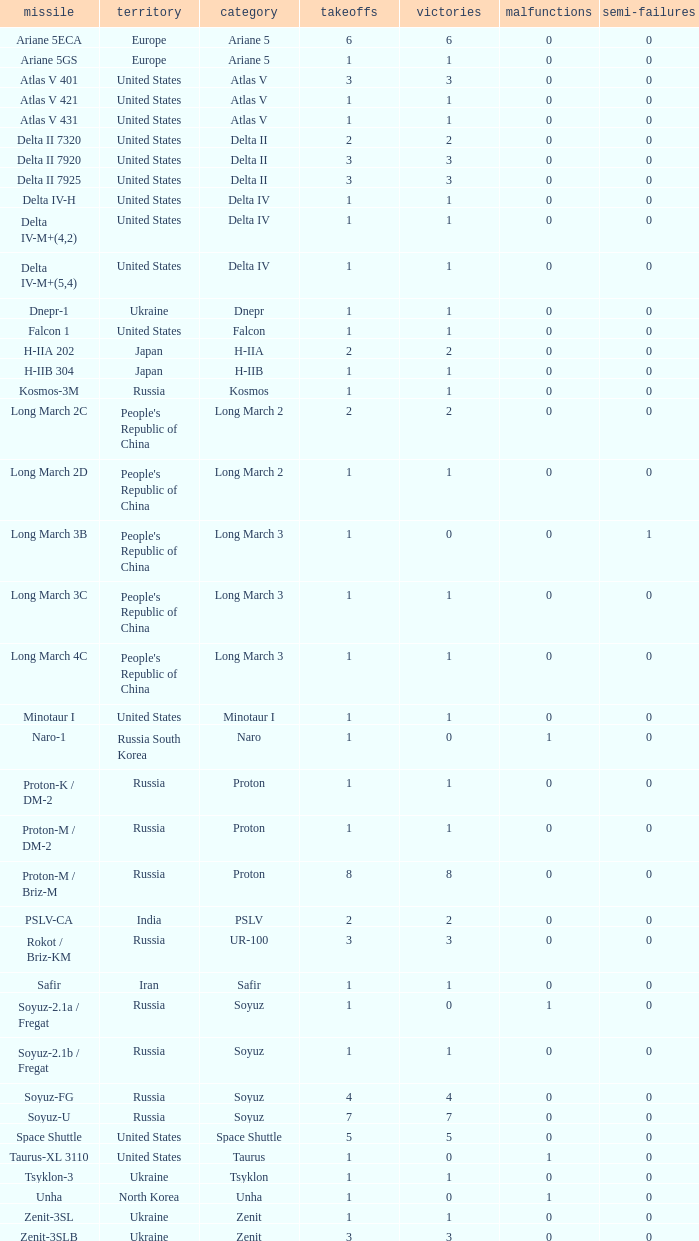What is the number of successes for rockets that have more than 3 launches, were based in Russia, are type soyuz and a rocket type of soyuz-u? 1.0. Could you parse the entire table? {'header': ['missile', 'territory', 'category', 'takeoffs', 'victories', 'malfunctions', 'semi-failures'], 'rows': [['Ariane 5ECA', 'Europe', 'Ariane 5', '6', '6', '0', '0'], ['Ariane 5GS', 'Europe', 'Ariane 5', '1', '1', '0', '0'], ['Atlas V 401', 'United States', 'Atlas V', '3', '3', '0', '0'], ['Atlas V 421', 'United States', 'Atlas V', '1', '1', '0', '0'], ['Atlas V 431', 'United States', 'Atlas V', '1', '1', '0', '0'], ['Delta II 7320', 'United States', 'Delta II', '2', '2', '0', '0'], ['Delta II 7920', 'United States', 'Delta II', '3', '3', '0', '0'], ['Delta II 7925', 'United States', 'Delta II', '3', '3', '0', '0'], ['Delta IV-H', 'United States', 'Delta IV', '1', '1', '0', '0'], ['Delta IV-M+(4,2)', 'United States', 'Delta IV', '1', '1', '0', '0'], ['Delta IV-M+(5,4)', 'United States', 'Delta IV', '1', '1', '0', '0'], ['Dnepr-1', 'Ukraine', 'Dnepr', '1', '1', '0', '0'], ['Falcon 1', 'United States', 'Falcon', '1', '1', '0', '0'], ['H-IIA 202', 'Japan', 'H-IIA', '2', '2', '0', '0'], ['H-IIB 304', 'Japan', 'H-IIB', '1', '1', '0', '0'], ['Kosmos-3M', 'Russia', 'Kosmos', '1', '1', '0', '0'], ['Long March 2C', "People's Republic of China", 'Long March 2', '2', '2', '0', '0'], ['Long March 2D', "People's Republic of China", 'Long March 2', '1', '1', '0', '0'], ['Long March 3B', "People's Republic of China", 'Long March 3', '1', '0', '0', '1'], ['Long March 3C', "People's Republic of China", 'Long March 3', '1', '1', '0', '0'], ['Long March 4C', "People's Republic of China", 'Long March 3', '1', '1', '0', '0'], ['Minotaur I', 'United States', 'Minotaur I', '1', '1', '0', '0'], ['Naro-1', 'Russia South Korea', 'Naro', '1', '0', '1', '0'], ['Proton-K / DM-2', 'Russia', 'Proton', '1', '1', '0', '0'], ['Proton-M / DM-2', 'Russia', 'Proton', '1', '1', '0', '0'], ['Proton-M / Briz-M', 'Russia', 'Proton', '8', '8', '0', '0'], ['PSLV-CA', 'India', 'PSLV', '2', '2', '0', '0'], ['Rokot / Briz-KM', 'Russia', 'UR-100', '3', '3', '0', '0'], ['Safir', 'Iran', 'Safir', '1', '1', '0', '0'], ['Soyuz-2.1a / Fregat', 'Russia', 'Soyuz', '1', '0', '1', '0'], ['Soyuz-2.1b / Fregat', 'Russia', 'Soyuz', '1', '1', '0', '0'], ['Soyuz-FG', 'Russia', 'Soyuz', '4', '4', '0', '0'], ['Soyuz-U', 'Russia', 'Soyuz', '7', '7', '0', '0'], ['Space Shuttle', 'United States', 'Space Shuttle', '5', '5', '0', '0'], ['Taurus-XL 3110', 'United States', 'Taurus', '1', '0', '1', '0'], ['Tsyklon-3', 'Ukraine', 'Tsyklon', '1', '1', '0', '0'], ['Unha', 'North Korea', 'Unha', '1', '0', '1', '0'], ['Zenit-3SL', 'Ukraine', 'Zenit', '1', '1', '0', '0'], ['Zenit-3SLB', 'Ukraine', 'Zenit', '3', '3', '0', '0']]} 